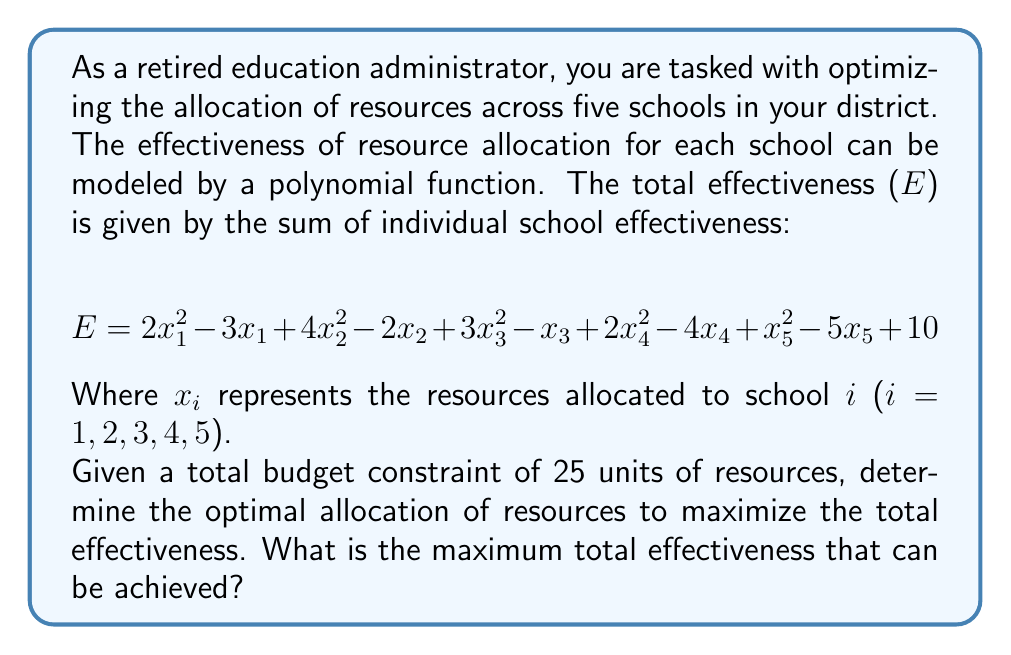Provide a solution to this math problem. To solve this optimization problem, we need to follow these steps:

1) First, we need to find the partial derivatives of E with respect to each $x_i$:

   $$\frac{\partial E}{\partial x_1} = 4x_1 - 3$$
   $$\frac{\partial E}{\partial x_2} = 8x_2 - 2$$
   $$\frac{\partial E}{\partial x_3} = 6x_3 - 1$$
   $$\frac{\partial E}{\partial x_4} = 4x_4 - 4$$
   $$\frac{\partial E}{\partial x_5} = 2x_5 - 5$$

2) At the maximum point, all these partial derivatives should be equal (due to the method of Lagrange multipliers). Let's call this common value λ:

   $$4x_1 - 3 = 8x_2 - 2 = 6x_3 - 1 = 4x_4 - 4 = 2x_5 - 5 = λ$$

3) From these equations, we can express each $x_i$ in terms of λ:

   $$x_1 = \frac{λ + 3}{4}, x_2 = \frac{λ + 2}{8}, x_3 = \frac{λ + 1}{6}, x_4 = \frac{λ + 4}{4}, x_5 = \frac{λ + 5}{2}$$

4) We know that the sum of all $x_i$ should equal the total budget of 25:

   $$\frac{λ + 3}{4} + \frac{λ + 2}{8} + \frac{λ + 1}{6} + \frac{λ + 4}{4} + \frac{λ + 5}{2} = 25$$

5) Solving this equation:

   $$\frac{3λ + 9}{12} + \frac{λ + 2}{8} + \frac{λ + 1}{6} + \frac{λ + 4}{4} + \frac{λ + 5}{2} = 25$$
   $$\frac{9λ + 27}{12} + \frac{3λ + 6}{24} + \frac{4λ + 4}{24} + \frac{6λ + 24}{24} + \frac{12λ + 60}{24} = 25$$
   $$\frac{18λ + 54}{24} + \frac{3λ + 6}{24} + \frac{4λ + 4}{24} + \frac{6λ + 24}{24} + \frac{12λ + 60}{24} = 25$$
   $$43λ + 148 = 600$$
   $$43λ = 452$$
   $$λ = \frac{452}{43} \approx 10.51$$

6) Now we can calculate each $x_i$:

   $$x_1 = \frac{10.51 + 3}{4} \approx 3.38$$
   $$x_2 = \frac{10.51 + 2}{8} \approx 1.56$$
   $$x_3 = \frac{10.51 + 1}{6} \approx 1.92$$
   $$x_4 = \frac{10.51 + 4}{4} \approx 3.63$$
   $$x_5 = \frac{10.51 + 5}{2} \approx 7.76$$

7) Finally, we can calculate the maximum effectiveness by plugging these values into the original equation:

   $$E = 2(3.38)^2 - 3(3.38) + 4(1.56)^2 - 2(1.56) + 3(1.92)^2 - 1(1.92) + 2(3.63)^2 - 4(3.63) + 1(7.76)^2 - 5(7.76) + 10$$
Answer: The maximum total effectiveness that can be achieved is approximately 65.72 units. 